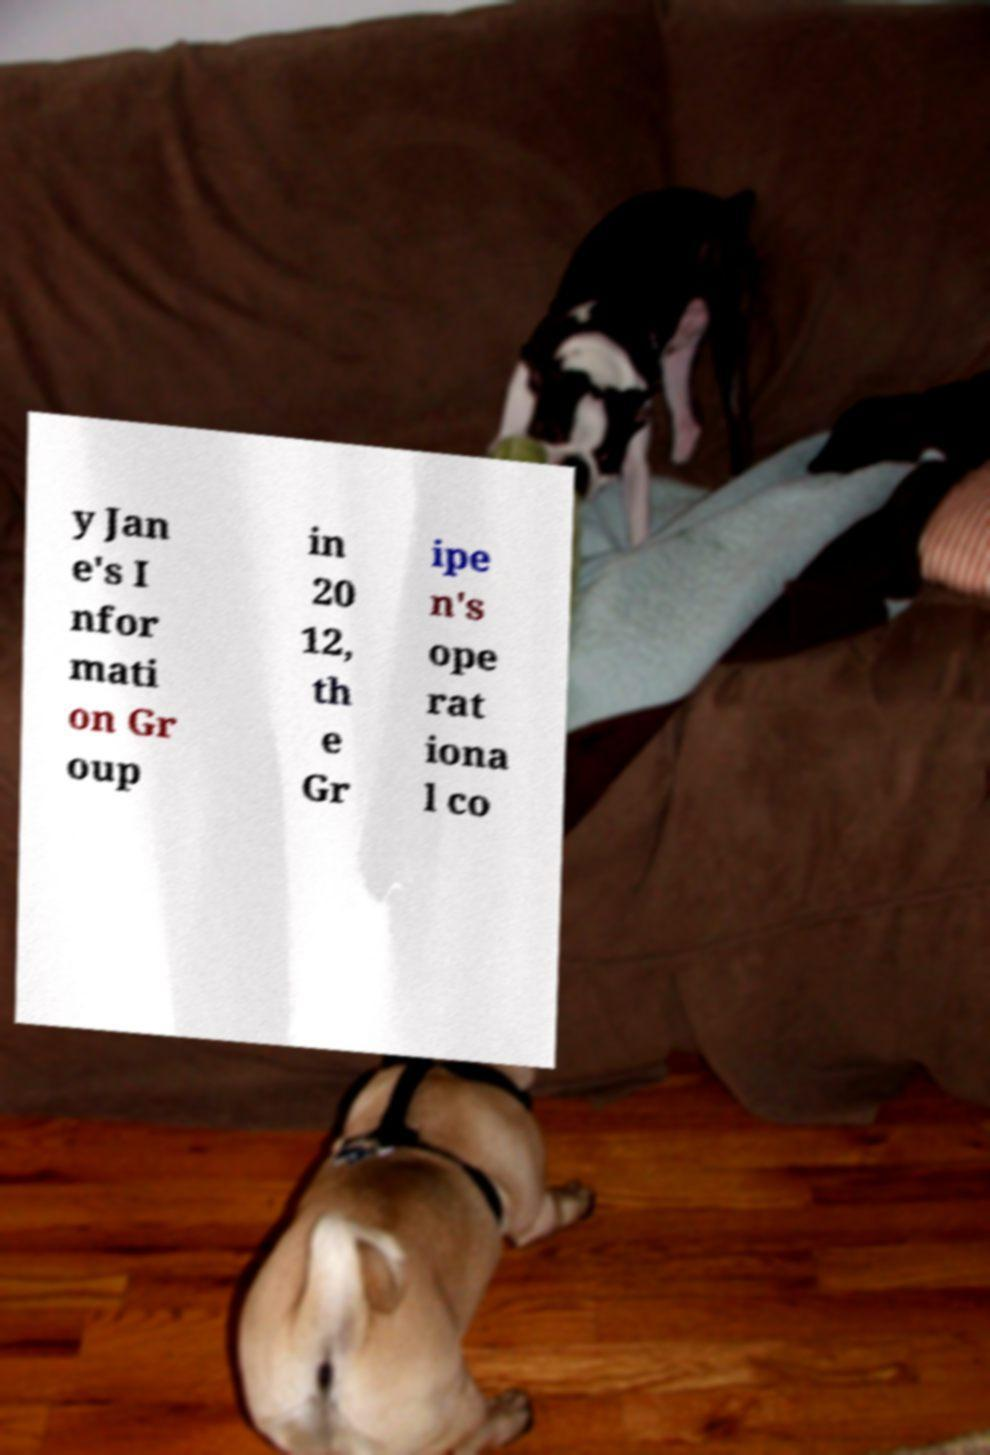What messages or text are displayed in this image? I need them in a readable, typed format. y Jan e's I nfor mati on Gr oup in 20 12, th e Gr ipe n's ope rat iona l co 